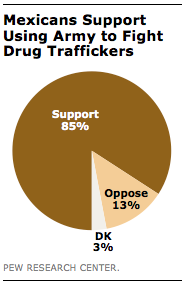Draw attention to some important aspects in this diagram. What is the largest value that can be represented by a number with a decimal point? According to a recent survey, 85% of Mexicans support the use of the military to combat drug trafficking. 